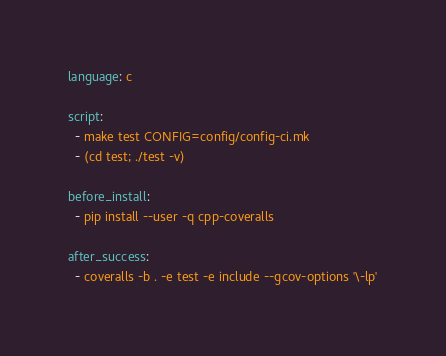<code> <loc_0><loc_0><loc_500><loc_500><_YAML_>language: c

script:
  - make test CONFIG=config/config-ci.mk
  - (cd test; ./test -v)

before_install:
  - pip install --user -q cpp-coveralls

after_success:
  - coveralls -b . -e test -e include --gcov-options '\-lp'

</code> 